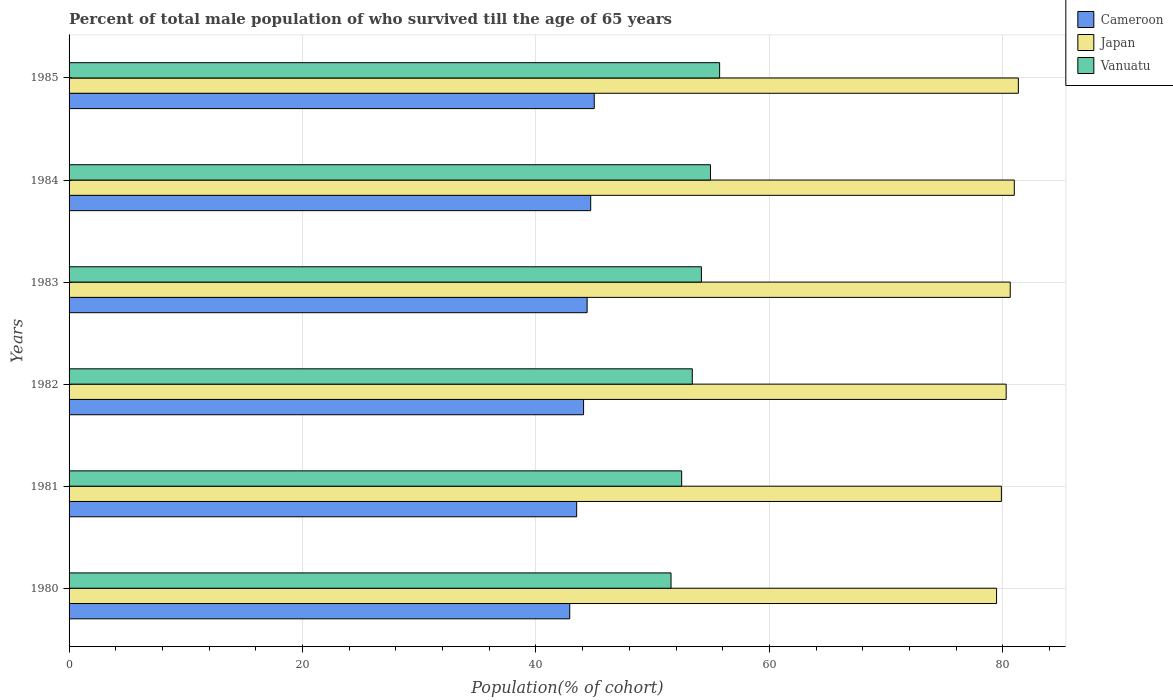How many different coloured bars are there?
Ensure brevity in your answer.  3. What is the label of the 5th group of bars from the top?
Make the answer very short. 1981. In how many cases, is the number of bars for a given year not equal to the number of legend labels?
Make the answer very short. 0. What is the percentage of total male population who survived till the age of 65 years in Cameroon in 1985?
Provide a succinct answer. 44.99. Across all years, what is the maximum percentage of total male population who survived till the age of 65 years in Cameroon?
Make the answer very short. 44.99. Across all years, what is the minimum percentage of total male population who survived till the age of 65 years in Japan?
Your answer should be very brief. 79.46. What is the total percentage of total male population who survived till the age of 65 years in Japan in the graph?
Ensure brevity in your answer.  482.56. What is the difference between the percentage of total male population who survived till the age of 65 years in Vanuatu in 1980 and that in 1982?
Give a very brief answer. -1.82. What is the difference between the percentage of total male population who survived till the age of 65 years in Japan in 1981 and the percentage of total male population who survived till the age of 65 years in Cameroon in 1984?
Offer a terse response. 35.18. What is the average percentage of total male population who survived till the age of 65 years in Cameroon per year?
Make the answer very short. 44.09. In the year 1985, what is the difference between the percentage of total male population who survived till the age of 65 years in Cameroon and percentage of total male population who survived till the age of 65 years in Japan?
Your response must be concise. -36.34. What is the ratio of the percentage of total male population who survived till the age of 65 years in Vanuatu in 1980 to that in 1983?
Your response must be concise. 0.95. Is the percentage of total male population who survived till the age of 65 years in Vanuatu in 1980 less than that in 1982?
Keep it short and to the point. Yes. What is the difference between the highest and the second highest percentage of total male population who survived till the age of 65 years in Japan?
Offer a terse response. 0.35. What is the difference between the highest and the lowest percentage of total male population who survived till the age of 65 years in Vanuatu?
Make the answer very short. 4.16. What does the 1st bar from the top in 1981 represents?
Make the answer very short. Vanuatu. What does the 1st bar from the bottom in 1980 represents?
Your answer should be very brief. Cameroon. Are all the bars in the graph horizontal?
Make the answer very short. Yes. Does the graph contain grids?
Provide a succinct answer. Yes. What is the title of the graph?
Your response must be concise. Percent of total male population of who survived till the age of 65 years. Does "Belarus" appear as one of the legend labels in the graph?
Give a very brief answer. No. What is the label or title of the X-axis?
Your answer should be very brief. Population(% of cohort). What is the label or title of the Y-axis?
Ensure brevity in your answer.  Years. What is the Population(% of cohort) of Cameroon in 1980?
Provide a succinct answer. 42.89. What is the Population(% of cohort) in Japan in 1980?
Offer a very short reply. 79.46. What is the Population(% of cohort) of Vanuatu in 1980?
Offer a very short reply. 51.57. What is the Population(% of cohort) in Cameroon in 1981?
Your answer should be very brief. 43.49. What is the Population(% of cohort) of Japan in 1981?
Your answer should be compact. 79.87. What is the Population(% of cohort) in Vanuatu in 1981?
Ensure brevity in your answer.  52.48. What is the Population(% of cohort) in Cameroon in 1982?
Ensure brevity in your answer.  44.08. What is the Population(% of cohort) in Japan in 1982?
Keep it short and to the point. 80.29. What is the Population(% of cohort) of Vanuatu in 1982?
Ensure brevity in your answer.  53.39. What is the Population(% of cohort) of Cameroon in 1983?
Your answer should be compact. 44.38. What is the Population(% of cohort) of Japan in 1983?
Provide a succinct answer. 80.63. What is the Population(% of cohort) of Vanuatu in 1983?
Your response must be concise. 54.17. What is the Population(% of cohort) in Cameroon in 1984?
Keep it short and to the point. 44.69. What is the Population(% of cohort) of Japan in 1984?
Your answer should be very brief. 80.98. What is the Population(% of cohort) of Vanuatu in 1984?
Your answer should be compact. 54.95. What is the Population(% of cohort) in Cameroon in 1985?
Keep it short and to the point. 44.99. What is the Population(% of cohort) in Japan in 1985?
Your answer should be very brief. 81.33. What is the Population(% of cohort) in Vanuatu in 1985?
Give a very brief answer. 55.74. Across all years, what is the maximum Population(% of cohort) in Cameroon?
Give a very brief answer. 44.99. Across all years, what is the maximum Population(% of cohort) of Japan?
Provide a succinct answer. 81.33. Across all years, what is the maximum Population(% of cohort) in Vanuatu?
Your answer should be very brief. 55.74. Across all years, what is the minimum Population(% of cohort) in Cameroon?
Your answer should be compact. 42.89. Across all years, what is the minimum Population(% of cohort) in Japan?
Ensure brevity in your answer.  79.46. Across all years, what is the minimum Population(% of cohort) in Vanuatu?
Offer a very short reply. 51.57. What is the total Population(% of cohort) of Cameroon in the graph?
Offer a terse response. 264.53. What is the total Population(% of cohort) in Japan in the graph?
Offer a terse response. 482.56. What is the total Population(% of cohort) in Vanuatu in the graph?
Offer a very short reply. 322.31. What is the difference between the Population(% of cohort) of Cameroon in 1980 and that in 1981?
Ensure brevity in your answer.  -0.59. What is the difference between the Population(% of cohort) in Japan in 1980 and that in 1981?
Keep it short and to the point. -0.41. What is the difference between the Population(% of cohort) of Vanuatu in 1980 and that in 1981?
Your response must be concise. -0.91. What is the difference between the Population(% of cohort) of Cameroon in 1980 and that in 1982?
Offer a very short reply. -1.19. What is the difference between the Population(% of cohort) in Japan in 1980 and that in 1982?
Provide a succinct answer. -0.82. What is the difference between the Population(% of cohort) in Vanuatu in 1980 and that in 1982?
Give a very brief answer. -1.82. What is the difference between the Population(% of cohort) of Cameroon in 1980 and that in 1983?
Give a very brief answer. -1.49. What is the difference between the Population(% of cohort) in Japan in 1980 and that in 1983?
Keep it short and to the point. -1.17. What is the difference between the Population(% of cohort) of Vanuatu in 1980 and that in 1983?
Make the answer very short. -2.6. What is the difference between the Population(% of cohort) of Cameroon in 1980 and that in 1984?
Keep it short and to the point. -1.79. What is the difference between the Population(% of cohort) of Japan in 1980 and that in 1984?
Keep it short and to the point. -1.52. What is the difference between the Population(% of cohort) in Vanuatu in 1980 and that in 1984?
Your response must be concise. -3.38. What is the difference between the Population(% of cohort) in Cameroon in 1980 and that in 1985?
Offer a terse response. -2.1. What is the difference between the Population(% of cohort) of Japan in 1980 and that in 1985?
Offer a very short reply. -1.87. What is the difference between the Population(% of cohort) in Vanuatu in 1980 and that in 1985?
Provide a short and direct response. -4.16. What is the difference between the Population(% of cohort) in Cameroon in 1981 and that in 1982?
Offer a terse response. -0.59. What is the difference between the Population(% of cohort) in Japan in 1981 and that in 1982?
Offer a very short reply. -0.41. What is the difference between the Population(% of cohort) of Vanuatu in 1981 and that in 1982?
Make the answer very short. -0.91. What is the difference between the Population(% of cohort) of Cameroon in 1981 and that in 1983?
Give a very brief answer. -0.9. What is the difference between the Population(% of cohort) in Japan in 1981 and that in 1983?
Give a very brief answer. -0.76. What is the difference between the Population(% of cohort) of Vanuatu in 1981 and that in 1983?
Your answer should be compact. -1.69. What is the difference between the Population(% of cohort) in Cameroon in 1981 and that in 1984?
Provide a succinct answer. -1.2. What is the difference between the Population(% of cohort) of Japan in 1981 and that in 1984?
Your answer should be very brief. -1.11. What is the difference between the Population(% of cohort) of Vanuatu in 1981 and that in 1984?
Your answer should be very brief. -2.47. What is the difference between the Population(% of cohort) in Cameroon in 1981 and that in 1985?
Provide a succinct answer. -1.51. What is the difference between the Population(% of cohort) of Japan in 1981 and that in 1985?
Keep it short and to the point. -1.46. What is the difference between the Population(% of cohort) in Vanuatu in 1981 and that in 1985?
Your answer should be very brief. -3.25. What is the difference between the Population(% of cohort) in Cameroon in 1982 and that in 1983?
Your answer should be very brief. -0.3. What is the difference between the Population(% of cohort) of Japan in 1982 and that in 1983?
Your answer should be very brief. -0.35. What is the difference between the Population(% of cohort) of Vanuatu in 1982 and that in 1983?
Your answer should be compact. -0.78. What is the difference between the Population(% of cohort) in Cameroon in 1982 and that in 1984?
Your answer should be compact. -0.61. What is the difference between the Population(% of cohort) of Japan in 1982 and that in 1984?
Offer a terse response. -0.7. What is the difference between the Population(% of cohort) in Vanuatu in 1982 and that in 1984?
Provide a succinct answer. -1.56. What is the difference between the Population(% of cohort) of Cameroon in 1982 and that in 1985?
Ensure brevity in your answer.  -0.91. What is the difference between the Population(% of cohort) of Japan in 1982 and that in 1985?
Make the answer very short. -1.04. What is the difference between the Population(% of cohort) of Vanuatu in 1982 and that in 1985?
Make the answer very short. -2.34. What is the difference between the Population(% of cohort) in Cameroon in 1983 and that in 1984?
Offer a very short reply. -0.3. What is the difference between the Population(% of cohort) in Japan in 1983 and that in 1984?
Provide a short and direct response. -0.35. What is the difference between the Population(% of cohort) of Vanuatu in 1983 and that in 1984?
Your answer should be very brief. -0.78. What is the difference between the Population(% of cohort) of Cameroon in 1983 and that in 1985?
Provide a short and direct response. -0.61. What is the difference between the Population(% of cohort) in Japan in 1983 and that in 1985?
Offer a terse response. -0.7. What is the difference between the Population(% of cohort) in Vanuatu in 1983 and that in 1985?
Your response must be concise. -1.56. What is the difference between the Population(% of cohort) of Cameroon in 1984 and that in 1985?
Your answer should be compact. -0.3. What is the difference between the Population(% of cohort) of Japan in 1984 and that in 1985?
Keep it short and to the point. -0.35. What is the difference between the Population(% of cohort) in Vanuatu in 1984 and that in 1985?
Provide a succinct answer. -0.78. What is the difference between the Population(% of cohort) of Cameroon in 1980 and the Population(% of cohort) of Japan in 1981?
Your response must be concise. -36.98. What is the difference between the Population(% of cohort) of Cameroon in 1980 and the Population(% of cohort) of Vanuatu in 1981?
Offer a terse response. -9.59. What is the difference between the Population(% of cohort) in Japan in 1980 and the Population(% of cohort) in Vanuatu in 1981?
Offer a very short reply. 26.98. What is the difference between the Population(% of cohort) of Cameroon in 1980 and the Population(% of cohort) of Japan in 1982?
Provide a short and direct response. -37.39. What is the difference between the Population(% of cohort) of Cameroon in 1980 and the Population(% of cohort) of Vanuatu in 1982?
Ensure brevity in your answer.  -10.5. What is the difference between the Population(% of cohort) in Japan in 1980 and the Population(% of cohort) in Vanuatu in 1982?
Keep it short and to the point. 26.07. What is the difference between the Population(% of cohort) in Cameroon in 1980 and the Population(% of cohort) in Japan in 1983?
Give a very brief answer. -37.74. What is the difference between the Population(% of cohort) of Cameroon in 1980 and the Population(% of cohort) of Vanuatu in 1983?
Offer a very short reply. -11.28. What is the difference between the Population(% of cohort) of Japan in 1980 and the Population(% of cohort) of Vanuatu in 1983?
Give a very brief answer. 25.29. What is the difference between the Population(% of cohort) of Cameroon in 1980 and the Population(% of cohort) of Japan in 1984?
Make the answer very short. -38.09. What is the difference between the Population(% of cohort) in Cameroon in 1980 and the Population(% of cohort) in Vanuatu in 1984?
Ensure brevity in your answer.  -12.06. What is the difference between the Population(% of cohort) in Japan in 1980 and the Population(% of cohort) in Vanuatu in 1984?
Provide a short and direct response. 24.51. What is the difference between the Population(% of cohort) in Cameroon in 1980 and the Population(% of cohort) in Japan in 1985?
Provide a succinct answer. -38.43. What is the difference between the Population(% of cohort) in Cameroon in 1980 and the Population(% of cohort) in Vanuatu in 1985?
Your response must be concise. -12.84. What is the difference between the Population(% of cohort) of Japan in 1980 and the Population(% of cohort) of Vanuatu in 1985?
Keep it short and to the point. 23.73. What is the difference between the Population(% of cohort) of Cameroon in 1981 and the Population(% of cohort) of Japan in 1982?
Keep it short and to the point. -36.8. What is the difference between the Population(% of cohort) of Cameroon in 1981 and the Population(% of cohort) of Vanuatu in 1982?
Your answer should be very brief. -9.91. What is the difference between the Population(% of cohort) of Japan in 1981 and the Population(% of cohort) of Vanuatu in 1982?
Provide a short and direct response. 26.48. What is the difference between the Population(% of cohort) in Cameroon in 1981 and the Population(% of cohort) in Japan in 1983?
Your answer should be very brief. -37.15. What is the difference between the Population(% of cohort) of Cameroon in 1981 and the Population(% of cohort) of Vanuatu in 1983?
Your response must be concise. -10.69. What is the difference between the Population(% of cohort) of Japan in 1981 and the Population(% of cohort) of Vanuatu in 1983?
Ensure brevity in your answer.  25.7. What is the difference between the Population(% of cohort) in Cameroon in 1981 and the Population(% of cohort) in Japan in 1984?
Offer a very short reply. -37.49. What is the difference between the Population(% of cohort) in Cameroon in 1981 and the Population(% of cohort) in Vanuatu in 1984?
Offer a terse response. -11.47. What is the difference between the Population(% of cohort) of Japan in 1981 and the Population(% of cohort) of Vanuatu in 1984?
Ensure brevity in your answer.  24.92. What is the difference between the Population(% of cohort) of Cameroon in 1981 and the Population(% of cohort) of Japan in 1985?
Ensure brevity in your answer.  -37.84. What is the difference between the Population(% of cohort) in Cameroon in 1981 and the Population(% of cohort) in Vanuatu in 1985?
Your answer should be very brief. -12.25. What is the difference between the Population(% of cohort) in Japan in 1981 and the Population(% of cohort) in Vanuatu in 1985?
Provide a succinct answer. 24.14. What is the difference between the Population(% of cohort) of Cameroon in 1982 and the Population(% of cohort) of Japan in 1983?
Ensure brevity in your answer.  -36.55. What is the difference between the Population(% of cohort) of Cameroon in 1982 and the Population(% of cohort) of Vanuatu in 1983?
Provide a succinct answer. -10.1. What is the difference between the Population(% of cohort) of Japan in 1982 and the Population(% of cohort) of Vanuatu in 1983?
Your answer should be very brief. 26.11. What is the difference between the Population(% of cohort) in Cameroon in 1982 and the Population(% of cohort) in Japan in 1984?
Ensure brevity in your answer.  -36.9. What is the difference between the Population(% of cohort) in Cameroon in 1982 and the Population(% of cohort) in Vanuatu in 1984?
Give a very brief answer. -10.88. What is the difference between the Population(% of cohort) of Japan in 1982 and the Population(% of cohort) of Vanuatu in 1984?
Keep it short and to the point. 25.33. What is the difference between the Population(% of cohort) of Cameroon in 1982 and the Population(% of cohort) of Japan in 1985?
Give a very brief answer. -37.25. What is the difference between the Population(% of cohort) of Cameroon in 1982 and the Population(% of cohort) of Vanuatu in 1985?
Your response must be concise. -11.66. What is the difference between the Population(% of cohort) of Japan in 1982 and the Population(% of cohort) of Vanuatu in 1985?
Offer a terse response. 24.55. What is the difference between the Population(% of cohort) in Cameroon in 1983 and the Population(% of cohort) in Japan in 1984?
Make the answer very short. -36.6. What is the difference between the Population(% of cohort) of Cameroon in 1983 and the Population(% of cohort) of Vanuatu in 1984?
Offer a terse response. -10.57. What is the difference between the Population(% of cohort) in Japan in 1983 and the Population(% of cohort) in Vanuatu in 1984?
Your response must be concise. 25.68. What is the difference between the Population(% of cohort) in Cameroon in 1983 and the Population(% of cohort) in Japan in 1985?
Your answer should be compact. -36.94. What is the difference between the Population(% of cohort) of Cameroon in 1983 and the Population(% of cohort) of Vanuatu in 1985?
Keep it short and to the point. -11.35. What is the difference between the Population(% of cohort) of Japan in 1983 and the Population(% of cohort) of Vanuatu in 1985?
Keep it short and to the point. 24.9. What is the difference between the Population(% of cohort) of Cameroon in 1984 and the Population(% of cohort) of Japan in 1985?
Make the answer very short. -36.64. What is the difference between the Population(% of cohort) of Cameroon in 1984 and the Population(% of cohort) of Vanuatu in 1985?
Offer a very short reply. -11.05. What is the difference between the Population(% of cohort) in Japan in 1984 and the Population(% of cohort) in Vanuatu in 1985?
Ensure brevity in your answer.  25.25. What is the average Population(% of cohort) in Cameroon per year?
Provide a short and direct response. 44.09. What is the average Population(% of cohort) in Japan per year?
Your answer should be compact. 80.43. What is the average Population(% of cohort) of Vanuatu per year?
Your answer should be compact. 53.72. In the year 1980, what is the difference between the Population(% of cohort) of Cameroon and Population(% of cohort) of Japan?
Offer a terse response. -36.57. In the year 1980, what is the difference between the Population(% of cohort) of Cameroon and Population(% of cohort) of Vanuatu?
Keep it short and to the point. -8.68. In the year 1980, what is the difference between the Population(% of cohort) of Japan and Population(% of cohort) of Vanuatu?
Make the answer very short. 27.89. In the year 1981, what is the difference between the Population(% of cohort) in Cameroon and Population(% of cohort) in Japan?
Your response must be concise. -36.39. In the year 1981, what is the difference between the Population(% of cohort) of Cameroon and Population(% of cohort) of Vanuatu?
Give a very brief answer. -9. In the year 1981, what is the difference between the Population(% of cohort) in Japan and Population(% of cohort) in Vanuatu?
Make the answer very short. 27.39. In the year 1982, what is the difference between the Population(% of cohort) of Cameroon and Population(% of cohort) of Japan?
Offer a terse response. -36.21. In the year 1982, what is the difference between the Population(% of cohort) of Cameroon and Population(% of cohort) of Vanuatu?
Offer a very short reply. -9.31. In the year 1982, what is the difference between the Population(% of cohort) in Japan and Population(% of cohort) in Vanuatu?
Provide a short and direct response. 26.89. In the year 1983, what is the difference between the Population(% of cohort) in Cameroon and Population(% of cohort) in Japan?
Ensure brevity in your answer.  -36.25. In the year 1983, what is the difference between the Population(% of cohort) in Cameroon and Population(% of cohort) in Vanuatu?
Offer a very short reply. -9.79. In the year 1983, what is the difference between the Population(% of cohort) of Japan and Population(% of cohort) of Vanuatu?
Offer a very short reply. 26.46. In the year 1984, what is the difference between the Population(% of cohort) of Cameroon and Population(% of cohort) of Japan?
Provide a succinct answer. -36.29. In the year 1984, what is the difference between the Population(% of cohort) in Cameroon and Population(% of cohort) in Vanuatu?
Provide a short and direct response. -10.27. In the year 1984, what is the difference between the Population(% of cohort) in Japan and Population(% of cohort) in Vanuatu?
Your response must be concise. 26.03. In the year 1985, what is the difference between the Population(% of cohort) in Cameroon and Population(% of cohort) in Japan?
Your response must be concise. -36.34. In the year 1985, what is the difference between the Population(% of cohort) in Cameroon and Population(% of cohort) in Vanuatu?
Offer a terse response. -10.74. In the year 1985, what is the difference between the Population(% of cohort) in Japan and Population(% of cohort) in Vanuatu?
Ensure brevity in your answer.  25.59. What is the ratio of the Population(% of cohort) in Cameroon in 1980 to that in 1981?
Offer a terse response. 0.99. What is the ratio of the Population(% of cohort) in Japan in 1980 to that in 1981?
Make the answer very short. 0.99. What is the ratio of the Population(% of cohort) of Vanuatu in 1980 to that in 1981?
Make the answer very short. 0.98. What is the ratio of the Population(% of cohort) in Cameroon in 1980 to that in 1982?
Your answer should be compact. 0.97. What is the ratio of the Population(% of cohort) in Japan in 1980 to that in 1982?
Make the answer very short. 0.99. What is the ratio of the Population(% of cohort) in Vanuatu in 1980 to that in 1982?
Ensure brevity in your answer.  0.97. What is the ratio of the Population(% of cohort) in Cameroon in 1980 to that in 1983?
Offer a very short reply. 0.97. What is the ratio of the Population(% of cohort) of Japan in 1980 to that in 1983?
Your answer should be very brief. 0.99. What is the ratio of the Population(% of cohort) in Cameroon in 1980 to that in 1984?
Keep it short and to the point. 0.96. What is the ratio of the Population(% of cohort) of Japan in 1980 to that in 1984?
Offer a terse response. 0.98. What is the ratio of the Population(% of cohort) in Vanuatu in 1980 to that in 1984?
Provide a short and direct response. 0.94. What is the ratio of the Population(% of cohort) in Cameroon in 1980 to that in 1985?
Your response must be concise. 0.95. What is the ratio of the Population(% of cohort) in Japan in 1980 to that in 1985?
Keep it short and to the point. 0.98. What is the ratio of the Population(% of cohort) of Vanuatu in 1980 to that in 1985?
Offer a very short reply. 0.93. What is the ratio of the Population(% of cohort) in Cameroon in 1981 to that in 1982?
Provide a short and direct response. 0.99. What is the ratio of the Population(% of cohort) of Japan in 1981 to that in 1982?
Offer a very short reply. 0.99. What is the ratio of the Population(% of cohort) of Vanuatu in 1981 to that in 1982?
Offer a terse response. 0.98. What is the ratio of the Population(% of cohort) of Cameroon in 1981 to that in 1983?
Your response must be concise. 0.98. What is the ratio of the Population(% of cohort) in Japan in 1981 to that in 1983?
Give a very brief answer. 0.99. What is the ratio of the Population(% of cohort) of Vanuatu in 1981 to that in 1983?
Offer a very short reply. 0.97. What is the ratio of the Population(% of cohort) of Cameroon in 1981 to that in 1984?
Your answer should be very brief. 0.97. What is the ratio of the Population(% of cohort) in Japan in 1981 to that in 1984?
Offer a very short reply. 0.99. What is the ratio of the Population(% of cohort) in Vanuatu in 1981 to that in 1984?
Make the answer very short. 0.95. What is the ratio of the Population(% of cohort) of Cameroon in 1981 to that in 1985?
Your answer should be compact. 0.97. What is the ratio of the Population(% of cohort) of Japan in 1981 to that in 1985?
Your answer should be very brief. 0.98. What is the ratio of the Population(% of cohort) in Vanuatu in 1981 to that in 1985?
Offer a terse response. 0.94. What is the ratio of the Population(% of cohort) in Japan in 1982 to that in 1983?
Provide a succinct answer. 1. What is the ratio of the Population(% of cohort) in Vanuatu in 1982 to that in 1983?
Your answer should be compact. 0.99. What is the ratio of the Population(% of cohort) in Cameroon in 1982 to that in 1984?
Your answer should be very brief. 0.99. What is the ratio of the Population(% of cohort) of Japan in 1982 to that in 1984?
Your answer should be compact. 0.99. What is the ratio of the Population(% of cohort) in Vanuatu in 1982 to that in 1984?
Ensure brevity in your answer.  0.97. What is the ratio of the Population(% of cohort) of Cameroon in 1982 to that in 1985?
Your response must be concise. 0.98. What is the ratio of the Population(% of cohort) of Japan in 1982 to that in 1985?
Ensure brevity in your answer.  0.99. What is the ratio of the Population(% of cohort) of Vanuatu in 1982 to that in 1985?
Your response must be concise. 0.96. What is the ratio of the Population(% of cohort) of Cameroon in 1983 to that in 1984?
Ensure brevity in your answer.  0.99. What is the ratio of the Population(% of cohort) in Vanuatu in 1983 to that in 1984?
Provide a succinct answer. 0.99. What is the ratio of the Population(% of cohort) of Cameroon in 1983 to that in 1985?
Your answer should be compact. 0.99. What is the ratio of the Population(% of cohort) in Japan in 1983 to that in 1985?
Offer a very short reply. 0.99. What is the ratio of the Population(% of cohort) of Japan in 1984 to that in 1985?
Give a very brief answer. 1. What is the ratio of the Population(% of cohort) of Vanuatu in 1984 to that in 1985?
Your answer should be compact. 0.99. What is the difference between the highest and the second highest Population(% of cohort) of Cameroon?
Offer a terse response. 0.3. What is the difference between the highest and the second highest Population(% of cohort) of Japan?
Make the answer very short. 0.35. What is the difference between the highest and the second highest Population(% of cohort) in Vanuatu?
Give a very brief answer. 0.78. What is the difference between the highest and the lowest Population(% of cohort) in Cameroon?
Keep it short and to the point. 2.1. What is the difference between the highest and the lowest Population(% of cohort) in Japan?
Provide a short and direct response. 1.87. What is the difference between the highest and the lowest Population(% of cohort) of Vanuatu?
Your answer should be very brief. 4.16. 